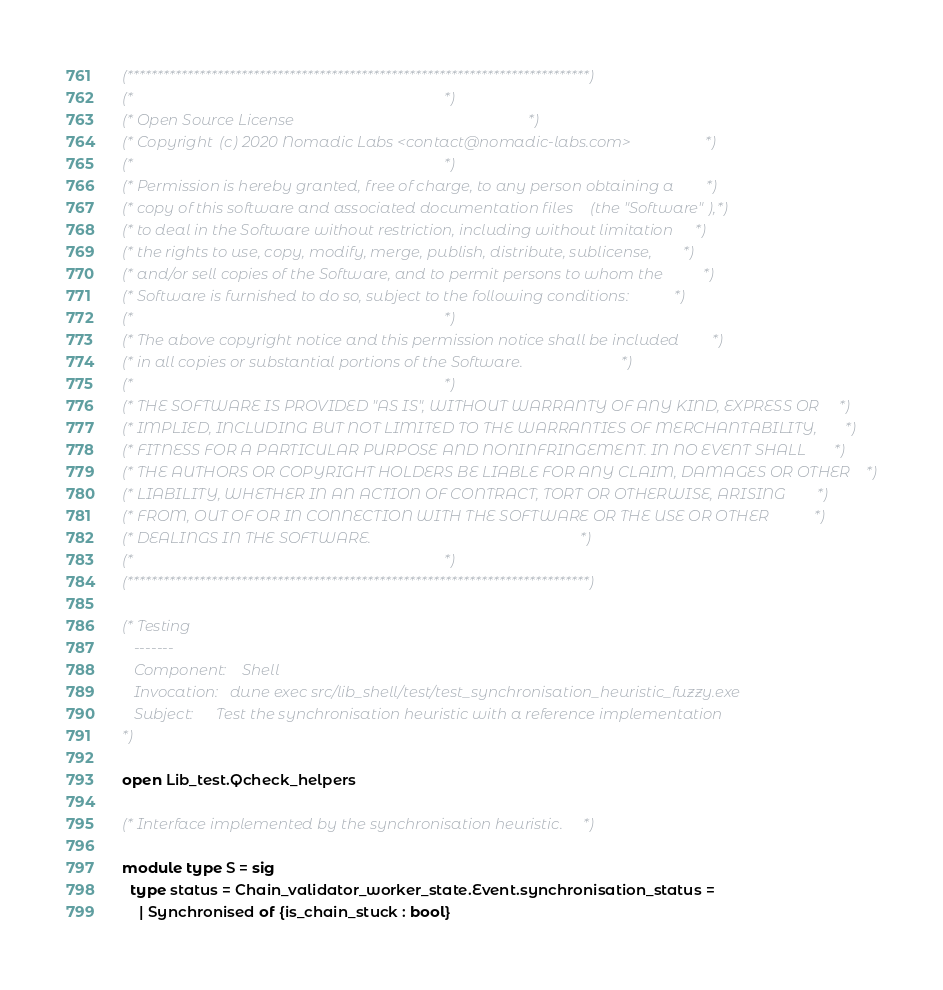<code> <loc_0><loc_0><loc_500><loc_500><_OCaml_>(*****************************************************************************)
(*                                                                           *)
(* Open Source License                                                       *)
(* Copyright (c) 2020 Nomadic Labs <contact@nomadic-labs.com>                *)
(*                                                                           *)
(* Permission is hereby granted, free of charge, to any person obtaining a   *)
(* copy of this software and associated documentation files (the "Software"),*)
(* to deal in the Software without restriction, including without limitation *)
(* the rights to use, copy, modify, merge, publish, distribute, sublicense,  *)
(* and/or sell copies of the Software, and to permit persons to whom the     *)
(* Software is furnished to do so, subject to the following conditions:      *)
(*                                                                           *)
(* The above copyright notice and this permission notice shall be included   *)
(* in all copies or substantial portions of the Software.                    *)
(*                                                                           *)
(* THE SOFTWARE IS PROVIDED "AS IS", WITHOUT WARRANTY OF ANY KIND, EXPRESS OR*)
(* IMPLIED, INCLUDING BUT NOT LIMITED TO THE WARRANTIES OF MERCHANTABILITY,  *)
(* FITNESS FOR A PARTICULAR PURPOSE AND NONINFRINGEMENT. IN NO EVENT SHALL   *)
(* THE AUTHORS OR COPYRIGHT HOLDERS BE LIABLE FOR ANY CLAIM, DAMAGES OR OTHER*)
(* LIABILITY, WHETHER IN AN ACTION OF CONTRACT, TORT OR OTHERWISE, ARISING   *)
(* FROM, OUT OF OR IN CONNECTION WITH THE SOFTWARE OR THE USE OR OTHER       *)
(* DEALINGS IN THE SOFTWARE.                                                 *)
(*                                                                           *)
(*****************************************************************************)

(* Testing
   -------
   Component:    Shell
   Invocation:   dune exec src/lib_shell/test/test_synchronisation_heuristic_fuzzy.exe
   Subject:      Test the synchronisation heuristic with a reference implementation
*)

open Lib_test.Qcheck_helpers

(* Interface implemented by the synchronisation heuristic. *)

module type S = sig
  type status = Chain_validator_worker_state.Event.synchronisation_status =
    | Synchronised of {is_chain_stuck : bool}</code> 